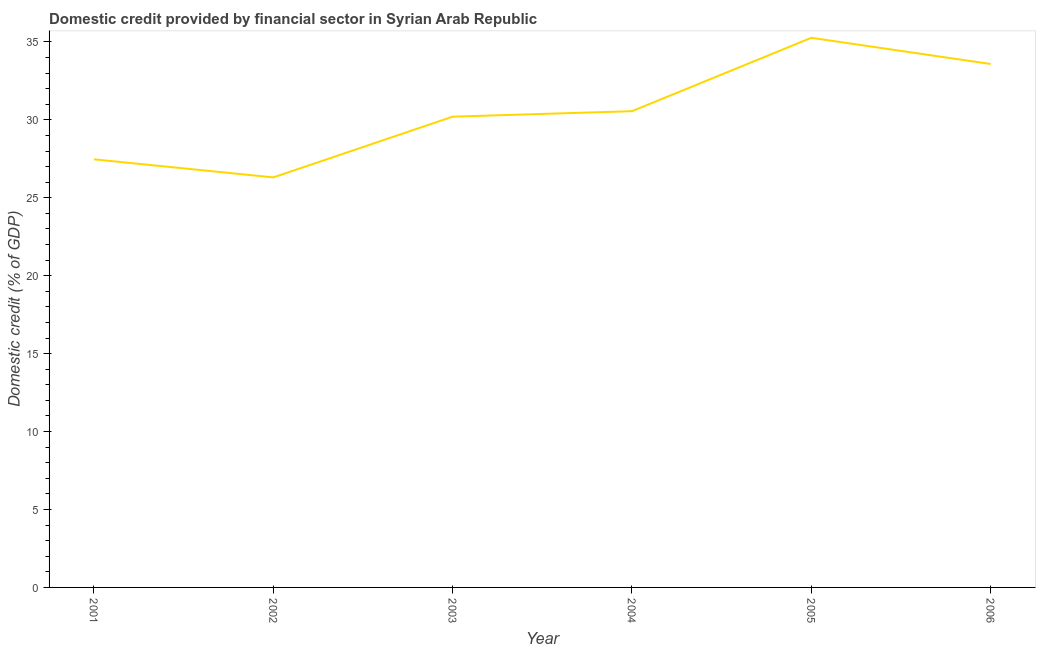What is the domestic credit provided by financial sector in 2001?
Keep it short and to the point. 27.47. Across all years, what is the maximum domestic credit provided by financial sector?
Ensure brevity in your answer.  35.26. Across all years, what is the minimum domestic credit provided by financial sector?
Give a very brief answer. 26.31. What is the sum of the domestic credit provided by financial sector?
Make the answer very short. 183.38. What is the difference between the domestic credit provided by financial sector in 2004 and 2005?
Ensure brevity in your answer.  -4.71. What is the average domestic credit provided by financial sector per year?
Ensure brevity in your answer.  30.56. What is the median domestic credit provided by financial sector?
Offer a terse response. 30.38. In how many years, is the domestic credit provided by financial sector greater than 28 %?
Provide a short and direct response. 4. Do a majority of the years between 2001 and 2005 (inclusive) have domestic credit provided by financial sector greater than 19 %?
Give a very brief answer. Yes. What is the ratio of the domestic credit provided by financial sector in 2003 to that in 2006?
Your answer should be compact. 0.9. Is the domestic credit provided by financial sector in 2001 less than that in 2004?
Provide a short and direct response. Yes. What is the difference between the highest and the second highest domestic credit provided by financial sector?
Give a very brief answer. 1.68. Is the sum of the domestic credit provided by financial sector in 2003 and 2006 greater than the maximum domestic credit provided by financial sector across all years?
Offer a terse response. Yes. What is the difference between the highest and the lowest domestic credit provided by financial sector?
Your answer should be compact. 8.96. In how many years, is the domestic credit provided by financial sector greater than the average domestic credit provided by financial sector taken over all years?
Offer a very short reply. 2. How many years are there in the graph?
Your answer should be very brief. 6. Are the values on the major ticks of Y-axis written in scientific E-notation?
Provide a short and direct response. No. What is the title of the graph?
Give a very brief answer. Domestic credit provided by financial sector in Syrian Arab Republic. What is the label or title of the Y-axis?
Your answer should be compact. Domestic credit (% of GDP). What is the Domestic credit (% of GDP) of 2001?
Keep it short and to the point. 27.47. What is the Domestic credit (% of GDP) in 2002?
Provide a short and direct response. 26.31. What is the Domestic credit (% of GDP) in 2003?
Your response must be concise. 30.2. What is the Domestic credit (% of GDP) in 2004?
Give a very brief answer. 30.55. What is the Domestic credit (% of GDP) of 2005?
Offer a very short reply. 35.26. What is the Domestic credit (% of GDP) of 2006?
Give a very brief answer. 33.58. What is the difference between the Domestic credit (% of GDP) in 2001 and 2002?
Keep it short and to the point. 1.16. What is the difference between the Domestic credit (% of GDP) in 2001 and 2003?
Your answer should be compact. -2.74. What is the difference between the Domestic credit (% of GDP) in 2001 and 2004?
Give a very brief answer. -3.09. What is the difference between the Domestic credit (% of GDP) in 2001 and 2005?
Your answer should be compact. -7.8. What is the difference between the Domestic credit (% of GDP) in 2001 and 2006?
Make the answer very short. -6.12. What is the difference between the Domestic credit (% of GDP) in 2002 and 2003?
Offer a very short reply. -3.9. What is the difference between the Domestic credit (% of GDP) in 2002 and 2004?
Provide a short and direct response. -4.25. What is the difference between the Domestic credit (% of GDP) in 2002 and 2005?
Provide a short and direct response. -8.96. What is the difference between the Domestic credit (% of GDP) in 2002 and 2006?
Your answer should be very brief. -7.28. What is the difference between the Domestic credit (% of GDP) in 2003 and 2004?
Give a very brief answer. -0.35. What is the difference between the Domestic credit (% of GDP) in 2003 and 2005?
Keep it short and to the point. -5.06. What is the difference between the Domestic credit (% of GDP) in 2003 and 2006?
Your answer should be very brief. -3.38. What is the difference between the Domestic credit (% of GDP) in 2004 and 2005?
Give a very brief answer. -4.71. What is the difference between the Domestic credit (% of GDP) in 2004 and 2006?
Make the answer very short. -3.03. What is the difference between the Domestic credit (% of GDP) in 2005 and 2006?
Offer a very short reply. 1.68. What is the ratio of the Domestic credit (% of GDP) in 2001 to that in 2002?
Your response must be concise. 1.04. What is the ratio of the Domestic credit (% of GDP) in 2001 to that in 2003?
Make the answer very short. 0.91. What is the ratio of the Domestic credit (% of GDP) in 2001 to that in 2004?
Provide a succinct answer. 0.9. What is the ratio of the Domestic credit (% of GDP) in 2001 to that in 2005?
Give a very brief answer. 0.78. What is the ratio of the Domestic credit (% of GDP) in 2001 to that in 2006?
Offer a terse response. 0.82. What is the ratio of the Domestic credit (% of GDP) in 2002 to that in 2003?
Make the answer very short. 0.87. What is the ratio of the Domestic credit (% of GDP) in 2002 to that in 2004?
Offer a terse response. 0.86. What is the ratio of the Domestic credit (% of GDP) in 2002 to that in 2005?
Your response must be concise. 0.75. What is the ratio of the Domestic credit (% of GDP) in 2002 to that in 2006?
Offer a terse response. 0.78. What is the ratio of the Domestic credit (% of GDP) in 2003 to that in 2004?
Ensure brevity in your answer.  0.99. What is the ratio of the Domestic credit (% of GDP) in 2003 to that in 2005?
Offer a very short reply. 0.86. What is the ratio of the Domestic credit (% of GDP) in 2003 to that in 2006?
Your answer should be very brief. 0.9. What is the ratio of the Domestic credit (% of GDP) in 2004 to that in 2005?
Your answer should be compact. 0.87. What is the ratio of the Domestic credit (% of GDP) in 2004 to that in 2006?
Your answer should be compact. 0.91. 